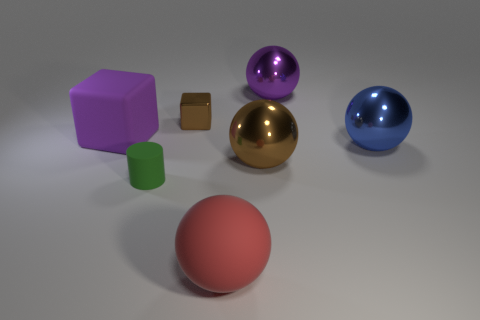Add 1 rubber cylinders. How many objects exist? 8 Subtract all cubes. How many objects are left? 5 Subtract all small yellow shiny cubes. Subtract all purple cubes. How many objects are left? 6 Add 7 brown cubes. How many brown cubes are left? 8 Add 4 large purple things. How many large purple things exist? 6 Subtract 0 yellow spheres. How many objects are left? 7 